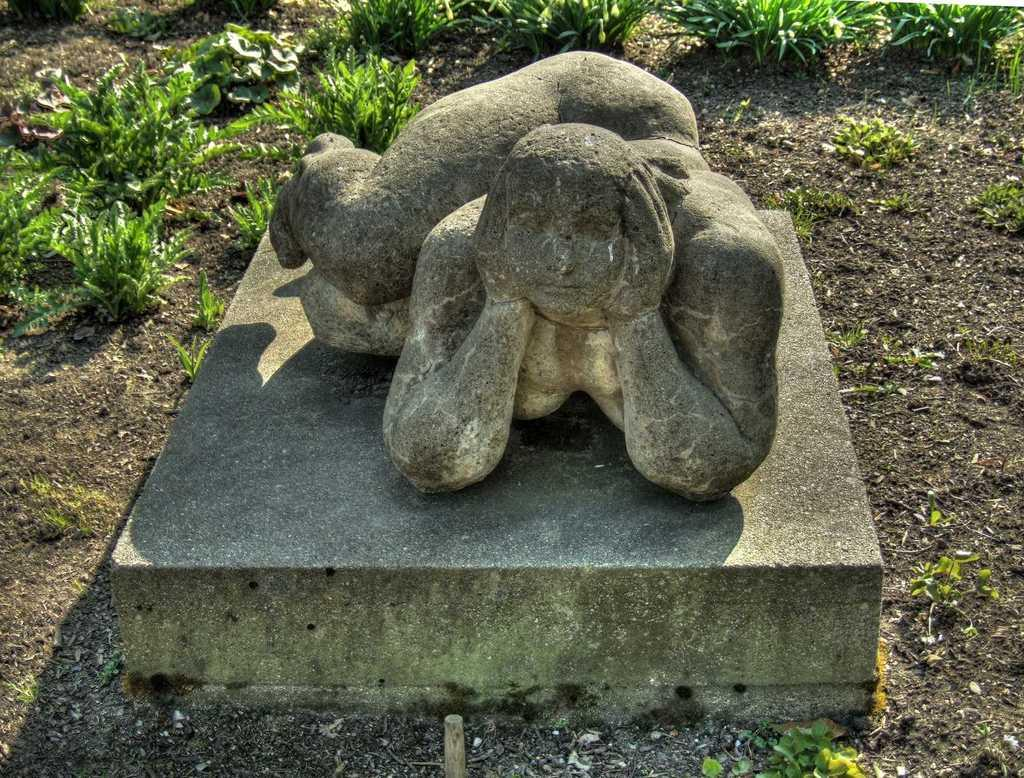What type of setting is depicted in the image? The image is an outside view. What is the main subject in the middle of the image? There is a sculpture in the middle of the image. What type of vegetation is visible at the top of the image? There are plants at the top of the image. What type of party is happening in the image? There is no party depicted in the image; it is an outside view with a sculpture and plants. What scientific theory is being demonstrated by the sculpture in the image? There is no specific scientific theory being demonstrated by the sculpture in the image; it is simply a sculpture in an outdoor setting. 